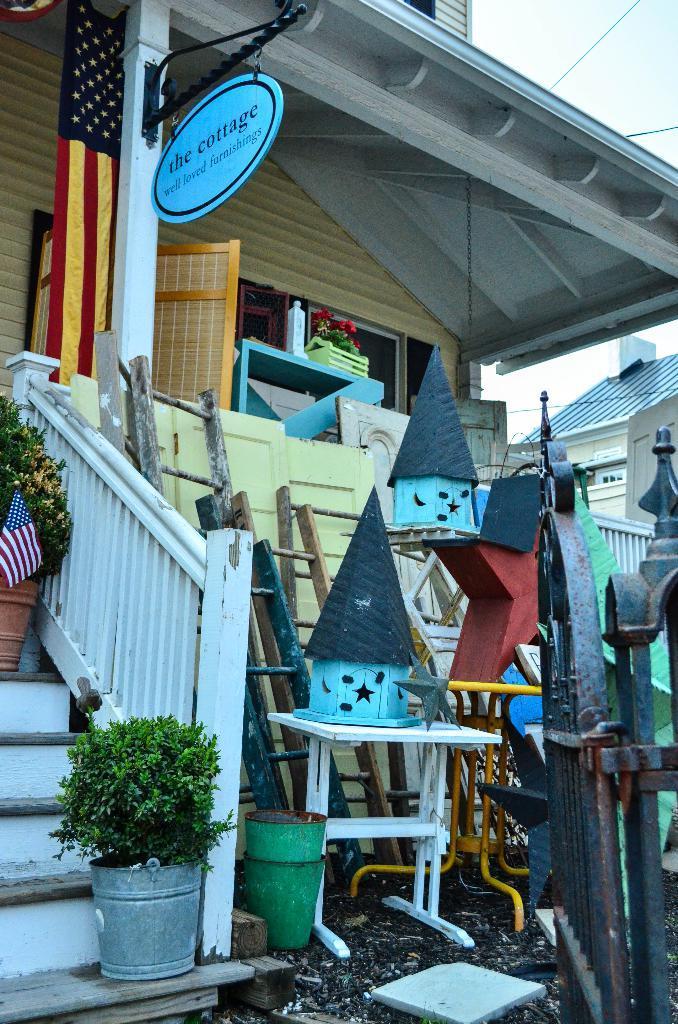Describe this image in one or two sentences. In this picture we can see houses with windows, tables, flags, ladders, gate and in the background we can see the sky. 